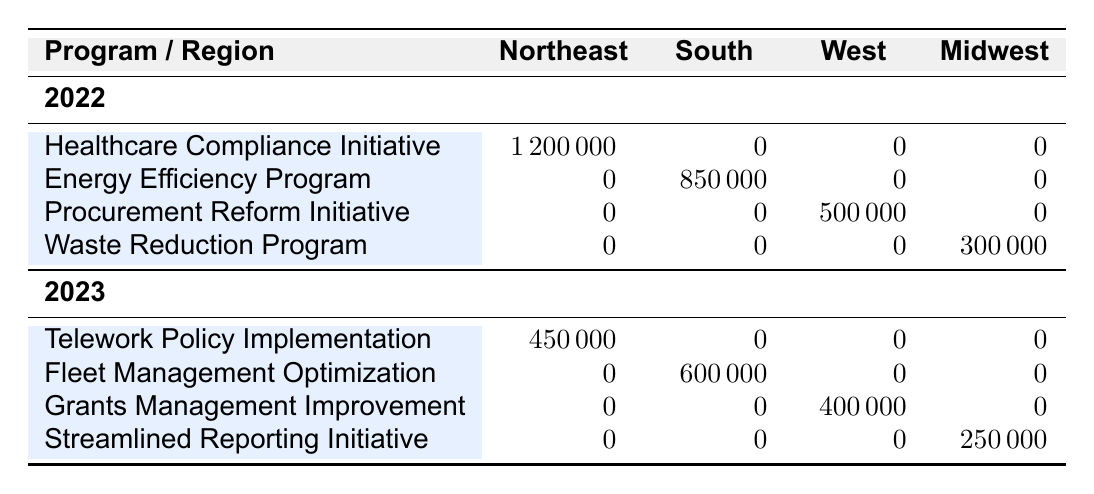What is the total cost savings achieved through the Healthcare Compliance Initiative in 2022? The table shows that the Healthcare Compliance Initiative achieved cost savings of 1,200,000 in the Northeast region in 2022.
Answer: 1,200,000 How much cost savings did the Energy Efficiency Program achieve in 2022? According to the table, the Energy Efficiency Program achieved cost savings of 850,000 in the South region in 2022.
Answer: 850,000 Which program achieved the highest cost savings in 2023? The highest cost savings in 2023 was achieved by the Fleet Management Optimization program, which saved 600,000 in the South region.
Answer: Fleet Management Optimization What is the total cost savings achieved in 2023 across all programs? In 2023, the cost savings from all programs are: Telework Policy Implementation (450,000) + Fleet Management Optimization (600,000) + Grants Management Improvement (400,000) + Streamlined Reporting Initiative (250,000) = 1,700,000.
Answer: 1,700,000 Is there a program that achieved cost savings in the Midwest region in 2022? The table indicates that there were no cost savings recorded in the Midwest region for any program in 2022 as all entries for that year in the Midwest region are zero.
Answer: No Did any program in 2022 achieve cost savings in the West region? The Procurement Reform Initiative achieved cost savings of 500,000 in the West region in 2022, confirming that there was indeed a program with recorded savings in that region.
Answer: Yes What is the difference in cost savings between the Waste Reduction Program in 2022 and the Streamlined Reporting Initiative in 2023? The Waste Reduction Program saved 300,000 in 2022, while the Streamlined Reporting Initiative saved 250,000 in 2023. The difference is 300,000 - 250,000 = 50,000.
Answer: 50,000 How much did the Telework Policy Implementation save compared to the Waste Reduction Program? The Telework Policy Implementation saved 450,000 in 2023 and the Waste Reduction Program saved 300,000 in 2022. The difference is 450,000 - 300,000 = 150,000.
Answer: 150,000 Which region had the least total cost savings across all programs for the year 2022? In 2022, the Midwest region had a total cost savings of 300,000 (from the Waste Reduction Program), which is less than the total savings in other regions (Northeast: 1,200,000; South: 850,000; West: 500,000). Thus, the Midwest had the least savings.
Answer: Midwest 